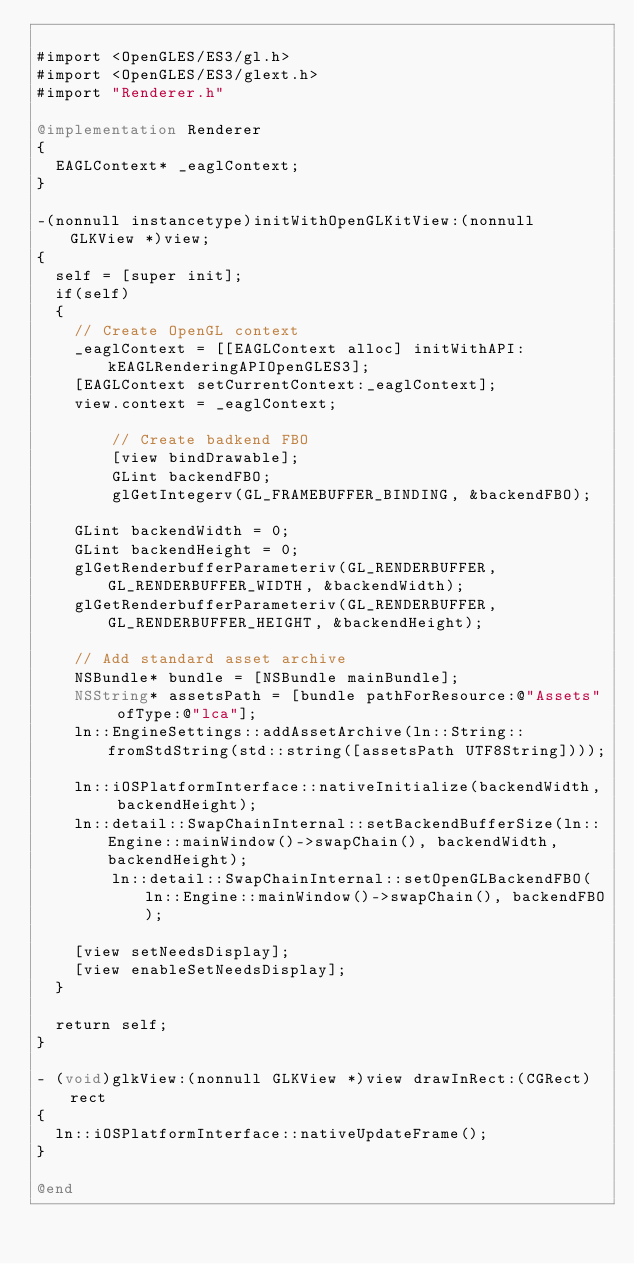<code> <loc_0><loc_0><loc_500><loc_500><_ObjectiveC_>
#import <OpenGLES/ES3/gl.h>
#import <OpenGLES/ES3/glext.h>
#import "Renderer.h"

@implementation Renderer
{
	EAGLContext* _eaglContext;
}

-(nonnull instancetype)initWithOpenGLKitView:(nonnull GLKView *)view;
{
	self = [super init];
	if(self)
	{
		// Create OpenGL context
		_eaglContext = [[EAGLContext alloc] initWithAPI:kEAGLRenderingAPIOpenGLES3];
		[EAGLContext setCurrentContext:_eaglContext];
		view.context = _eaglContext;
		
        // Create badkend FBO
        [view bindDrawable];
        GLint backendFBO;
        glGetIntegerv(GL_FRAMEBUFFER_BINDING, &backendFBO);
		
		GLint backendWidth = 0;
		GLint backendHeight = 0;
		glGetRenderbufferParameteriv(GL_RENDERBUFFER, GL_RENDERBUFFER_WIDTH, &backendWidth);
		glGetRenderbufferParameteriv(GL_RENDERBUFFER, GL_RENDERBUFFER_HEIGHT, &backendHeight);
		
		// Add standard asset archive
		NSBundle* bundle = [NSBundle mainBundle];
		NSString* assetsPath = [bundle pathForResource:@"Assets" ofType:@"lca"];
		ln::EngineSettings::addAssetArchive(ln::String::fromStdString(std::string([assetsPath UTF8String])));
		
		ln::iOSPlatformInterface::nativeInitialize(backendWidth, backendHeight);
		ln::detail::SwapChainInternal::setBackendBufferSize(ln::Engine::mainWindow()->swapChain(), backendWidth, backendHeight);
        ln::detail::SwapChainInternal::setOpenGLBackendFBO(ln::Engine::mainWindow()->swapChain(), backendFBO);
		
		[view setNeedsDisplay];
		[view enableSetNeedsDisplay];
	}
	
	return self;
}

- (void)glkView:(nonnull GLKView *)view drawInRect:(CGRect)rect
{
	ln::iOSPlatformInterface::nativeUpdateFrame();
}

@end
</code> 